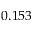<formula> <loc_0><loc_0><loc_500><loc_500>0 . 1 5 3</formula> 